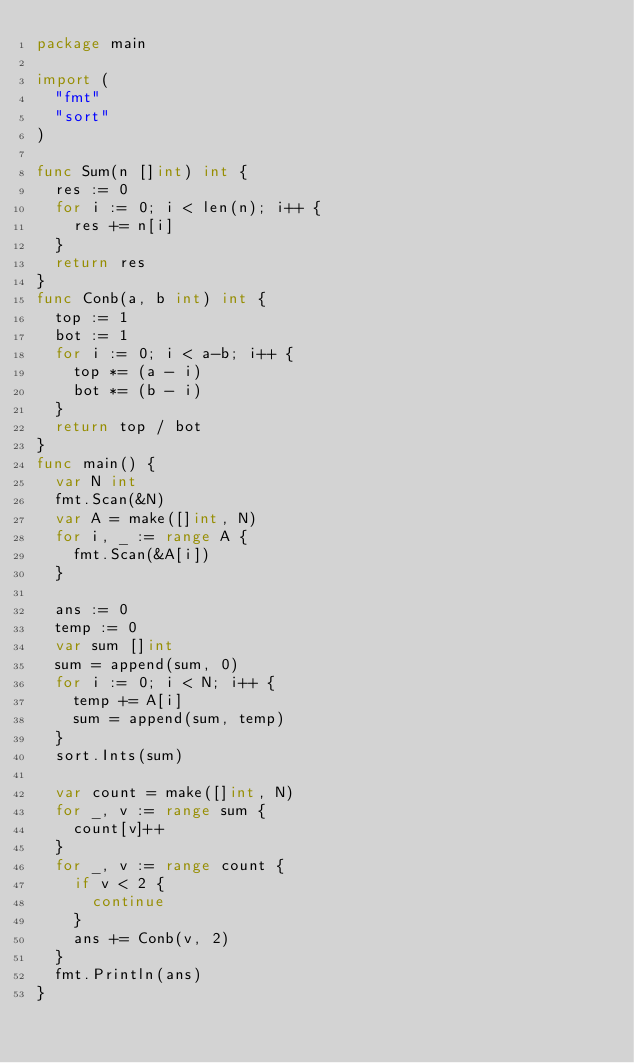Convert code to text. <code><loc_0><loc_0><loc_500><loc_500><_Go_>package main

import (
	"fmt"
	"sort"
)

func Sum(n []int) int {
	res := 0
	for i := 0; i < len(n); i++ {
		res += n[i]
	}
	return res
}
func Conb(a, b int) int {
	top := 1
	bot := 1
	for i := 0; i < a-b; i++ {
		top *= (a - i)
		bot *= (b - i)
	}
	return top / bot
}
func main() {
	var N int
	fmt.Scan(&N)
	var A = make([]int, N)
	for i, _ := range A {
		fmt.Scan(&A[i])
	}

	ans := 0
	temp := 0
	var sum []int
	sum = append(sum, 0)
	for i := 0; i < N; i++ {
		temp += A[i]
		sum = append(sum, temp)
	}
	sort.Ints(sum)

	var count = make([]int, N)
	for _, v := range sum {
		count[v]++
	}
	for _, v := range count {
		if v < 2 {
			continue
		}
		ans += Conb(v, 2)
	}
	fmt.Println(ans)
}</code> 